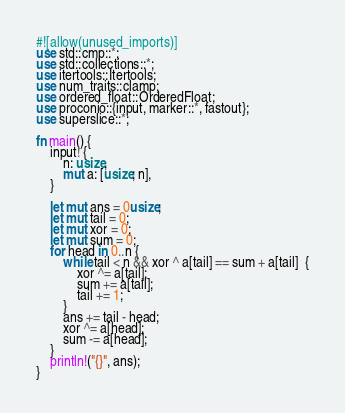<code> <loc_0><loc_0><loc_500><loc_500><_Rust_>#![allow(unused_imports)]
use std::cmp::*;
use std::collections::*;
use itertools::Itertools;
use num_traits::clamp;
use ordered_float::OrderedFloat;
use proconio::{input, marker::*, fastout};
use superslice::*;

fn main() {
    input! {
        n: usize,
        mut a: [usize; n],
    }

    let mut ans = 0usize;
    let mut tail = 0;
    let mut xor = 0;
    let mut sum = 0;
    for head in 0..n {
        while tail < n && xor ^ a[tail] == sum + a[tail]  {
            xor ^= a[tail];
            sum += a[tail];
            tail += 1;
        }
        ans += tail - head;
        xor ^= a[head];
        sum -= a[head];
    }
    println!("{}", ans);
}
</code> 